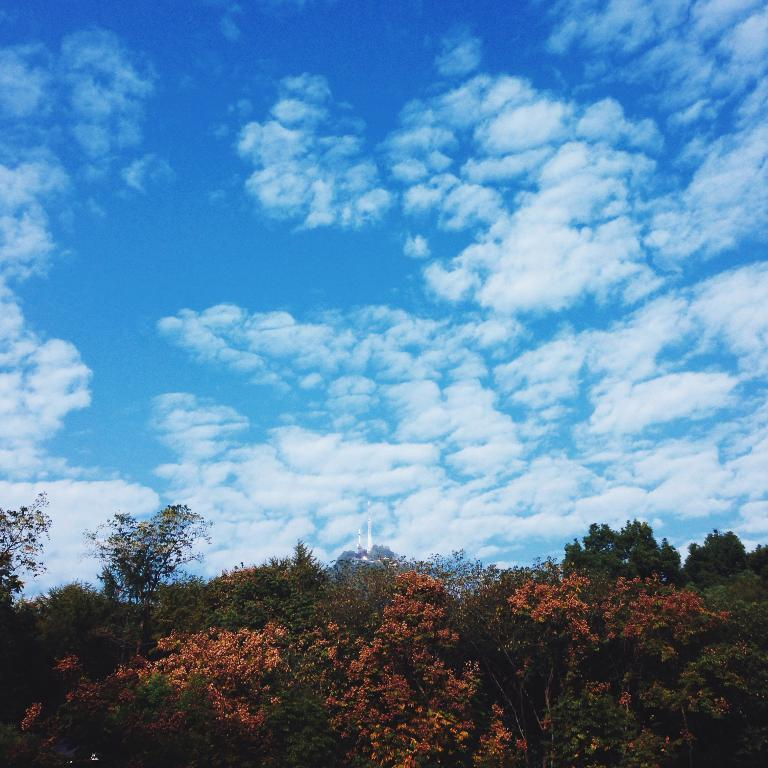What type of vegetation can be seen in the image? There are trees in the image. What part of the natural environment is visible in the image? The sky is visible in the image. How would you describe the sky's condition in the image? The sky appears to be a bit cloudy in the image. Can you see any fire or flames in the image? No, there is no fire or flames present in the image. Is there a tiger visible among the trees in the image? No, there is no tiger visible in the image; only trees are present. 